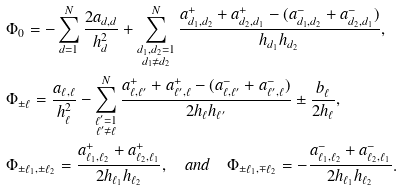Convert formula to latex. <formula><loc_0><loc_0><loc_500><loc_500>& \Phi _ { 0 } = - \sum _ { d = 1 } ^ { N } \frac { 2 a _ { d , d } } { h _ { d } ^ { 2 } } + \sum _ { \substack { d _ { 1 } , d _ { 2 } = 1 \\ d _ { 1 } \neq d _ { 2 } } } ^ { N } \frac { a _ { d _ { 1 } , d _ { 2 } } ^ { + } + a _ { d _ { 2 } , d _ { 1 } } ^ { + } - ( a _ { d _ { 1 } , d _ { 2 } } ^ { - } + a _ { d _ { 2 } , d _ { 1 } } ^ { - } ) } { h _ { d _ { 1 } } h _ { d _ { 2 } } } , \\ & \Phi _ { \pm \ell } = \frac { a _ { \ell , \ell } } { h _ { \ell } ^ { 2 } } - \sum _ { \substack { \ell ^ { \prime } = 1 \\ \ell ^ { \prime } \neq \ell } } ^ { N } \frac { a _ { \ell , \ell ^ { \prime } } ^ { + } + a _ { \ell ^ { \prime } , \ell } ^ { + } - ( a _ { \ell , \ell ^ { \prime } } ^ { - } + a _ { \ell ^ { \prime } , \ell } ^ { - } ) } { 2 h _ { \ell } h _ { \ell ^ { \prime } } } \pm \frac { b _ { \ell } } { 2 h _ { \ell } } , \\ & \Phi _ { \pm \ell _ { 1 } , \pm \ell _ { 2 } } = \frac { a _ { \ell _ { 1 } , \ell _ { 2 } } ^ { + } + a _ { \ell _ { 2 } , \ell _ { 1 } } ^ { + } } { 2 h _ { \ell _ { 1 } } h _ { \ell _ { 2 } } } , \quad a n d \quad \Phi _ { \pm \ell _ { 1 } , \mp \ell _ { 2 } } = - \frac { a _ { \ell _ { 1 } , \ell _ { 2 } } ^ { - } + a _ { \ell _ { 2 } , \ell _ { 1 } } ^ { - } } { 2 h _ { \ell _ { 1 } } h _ { \ell _ { 2 } } } .</formula> 